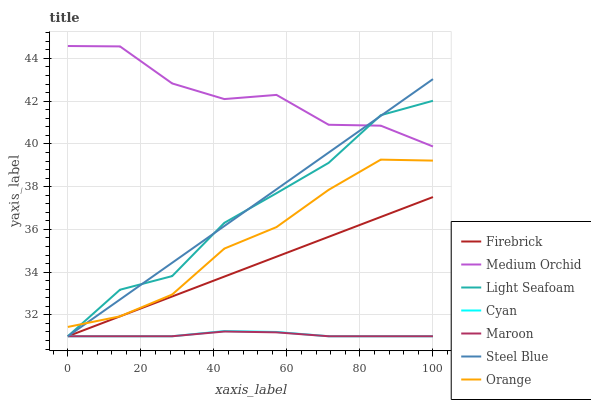Does Maroon have the minimum area under the curve?
Answer yes or no. Yes. Does Medium Orchid have the maximum area under the curve?
Answer yes or no. Yes. Does Steel Blue have the minimum area under the curve?
Answer yes or no. No. Does Steel Blue have the maximum area under the curve?
Answer yes or no. No. Is Steel Blue the smoothest?
Answer yes or no. Yes. Is Medium Orchid the roughest?
Answer yes or no. Yes. Is Medium Orchid the smoothest?
Answer yes or no. No. Is Steel Blue the roughest?
Answer yes or no. No. Does Firebrick have the lowest value?
Answer yes or no. Yes. Does Medium Orchid have the lowest value?
Answer yes or no. No. Does Medium Orchid have the highest value?
Answer yes or no. Yes. Does Steel Blue have the highest value?
Answer yes or no. No. Is Cyan less than Medium Orchid?
Answer yes or no. Yes. Is Medium Orchid greater than Firebrick?
Answer yes or no. Yes. Does Cyan intersect Maroon?
Answer yes or no. Yes. Is Cyan less than Maroon?
Answer yes or no. No. Is Cyan greater than Maroon?
Answer yes or no. No. Does Cyan intersect Medium Orchid?
Answer yes or no. No. 